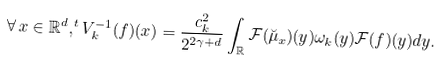Convert formula to latex. <formula><loc_0><loc_0><loc_500><loc_500>\forall \, x \in \mathbb { R } ^ { d } , ^ { t } V _ { k } ^ { - 1 } ( f ) ( x ) = \frac { c ^ { 2 } _ { k } } { 2 ^ { 2 \gamma + d } } \int _ { \mathbb { R } } \mathcal { F } ( \breve { \mu } _ { x } ) ( y ) \omega _ { k } ( y ) \mathcal { F } ( f ) ( y ) d y .</formula> 